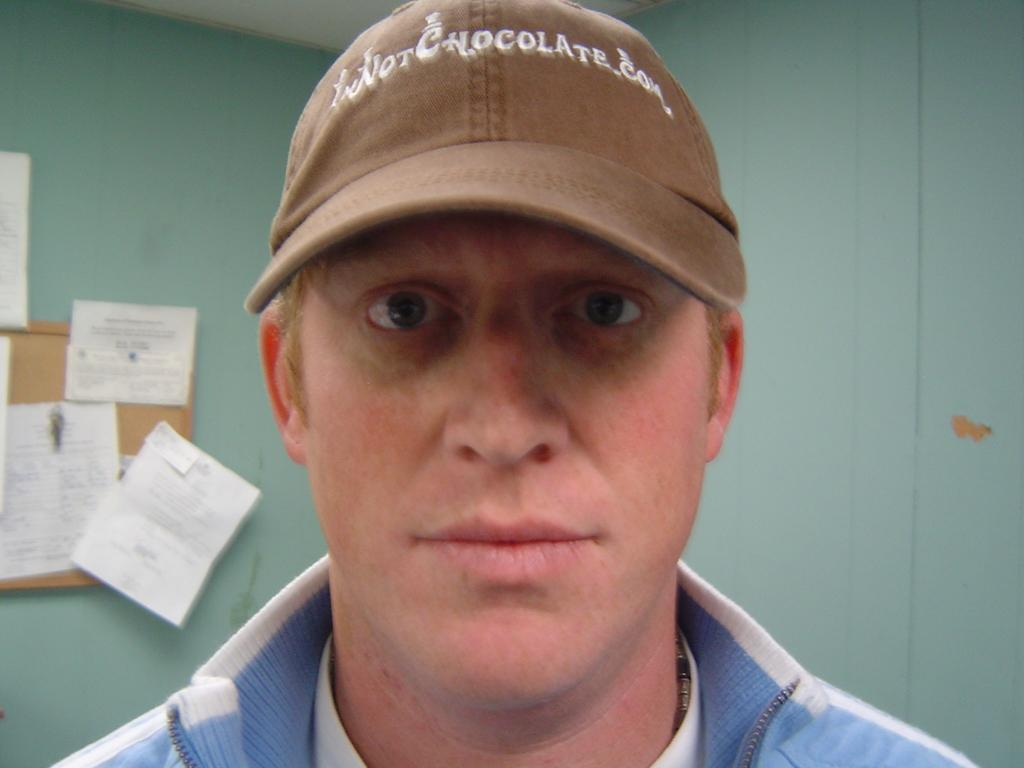Who or what is present in the image? There is a person in the image. Can you describe the person's attire? The person is wearing a cap. What can be seen in the background of the image? There are walls visible in the background of the image. What type of information might be available from the wooden board in the image? There are pamphlets on a wooden board in the image, which might contain information or advertisements. Where is the tub located in the image? There is no tub present in the image. Can you describe the type of swing the person is using in the image? There is no swing present in the image. 